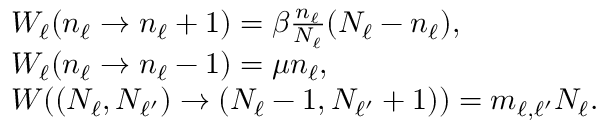<formula> <loc_0><loc_0><loc_500><loc_500>\begin{array} { r l } & { W _ { \ell } ( n _ { \ell } \rightarrow n _ { \ell } + 1 ) = \beta \frac { n _ { \ell } } { N _ { \ell } } ( N _ { \ell } - n _ { \ell } ) , } \\ & { W _ { \ell } ( n _ { \ell } \rightarrow n _ { \ell } - 1 ) = \mu n _ { \ell } , } \\ & { W ( ( N _ { \ell } , N _ { \ell ^ { \prime } } ) \rightarrow ( N _ { \ell } - 1 , N _ { \ell ^ { \prime } } + 1 ) ) = m _ { \ell , \ell ^ { \prime } } N _ { \ell } . } \end{array}</formula> 